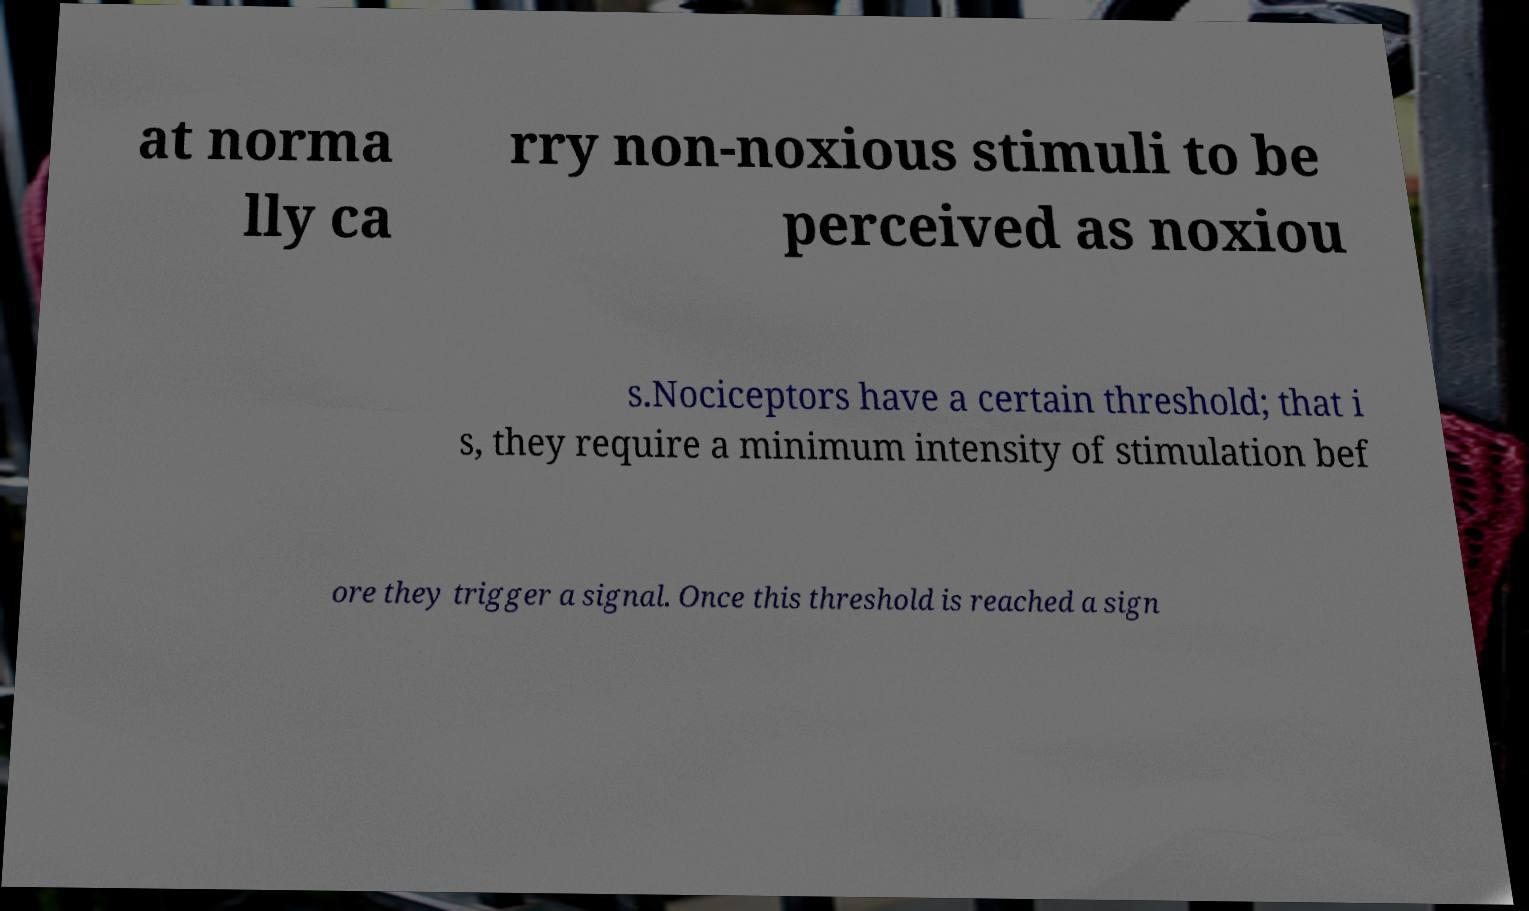For documentation purposes, I need the text within this image transcribed. Could you provide that? at norma lly ca rry non-noxious stimuli to be perceived as noxiou s.Nociceptors have a certain threshold; that i s, they require a minimum intensity of stimulation bef ore they trigger a signal. Once this threshold is reached a sign 